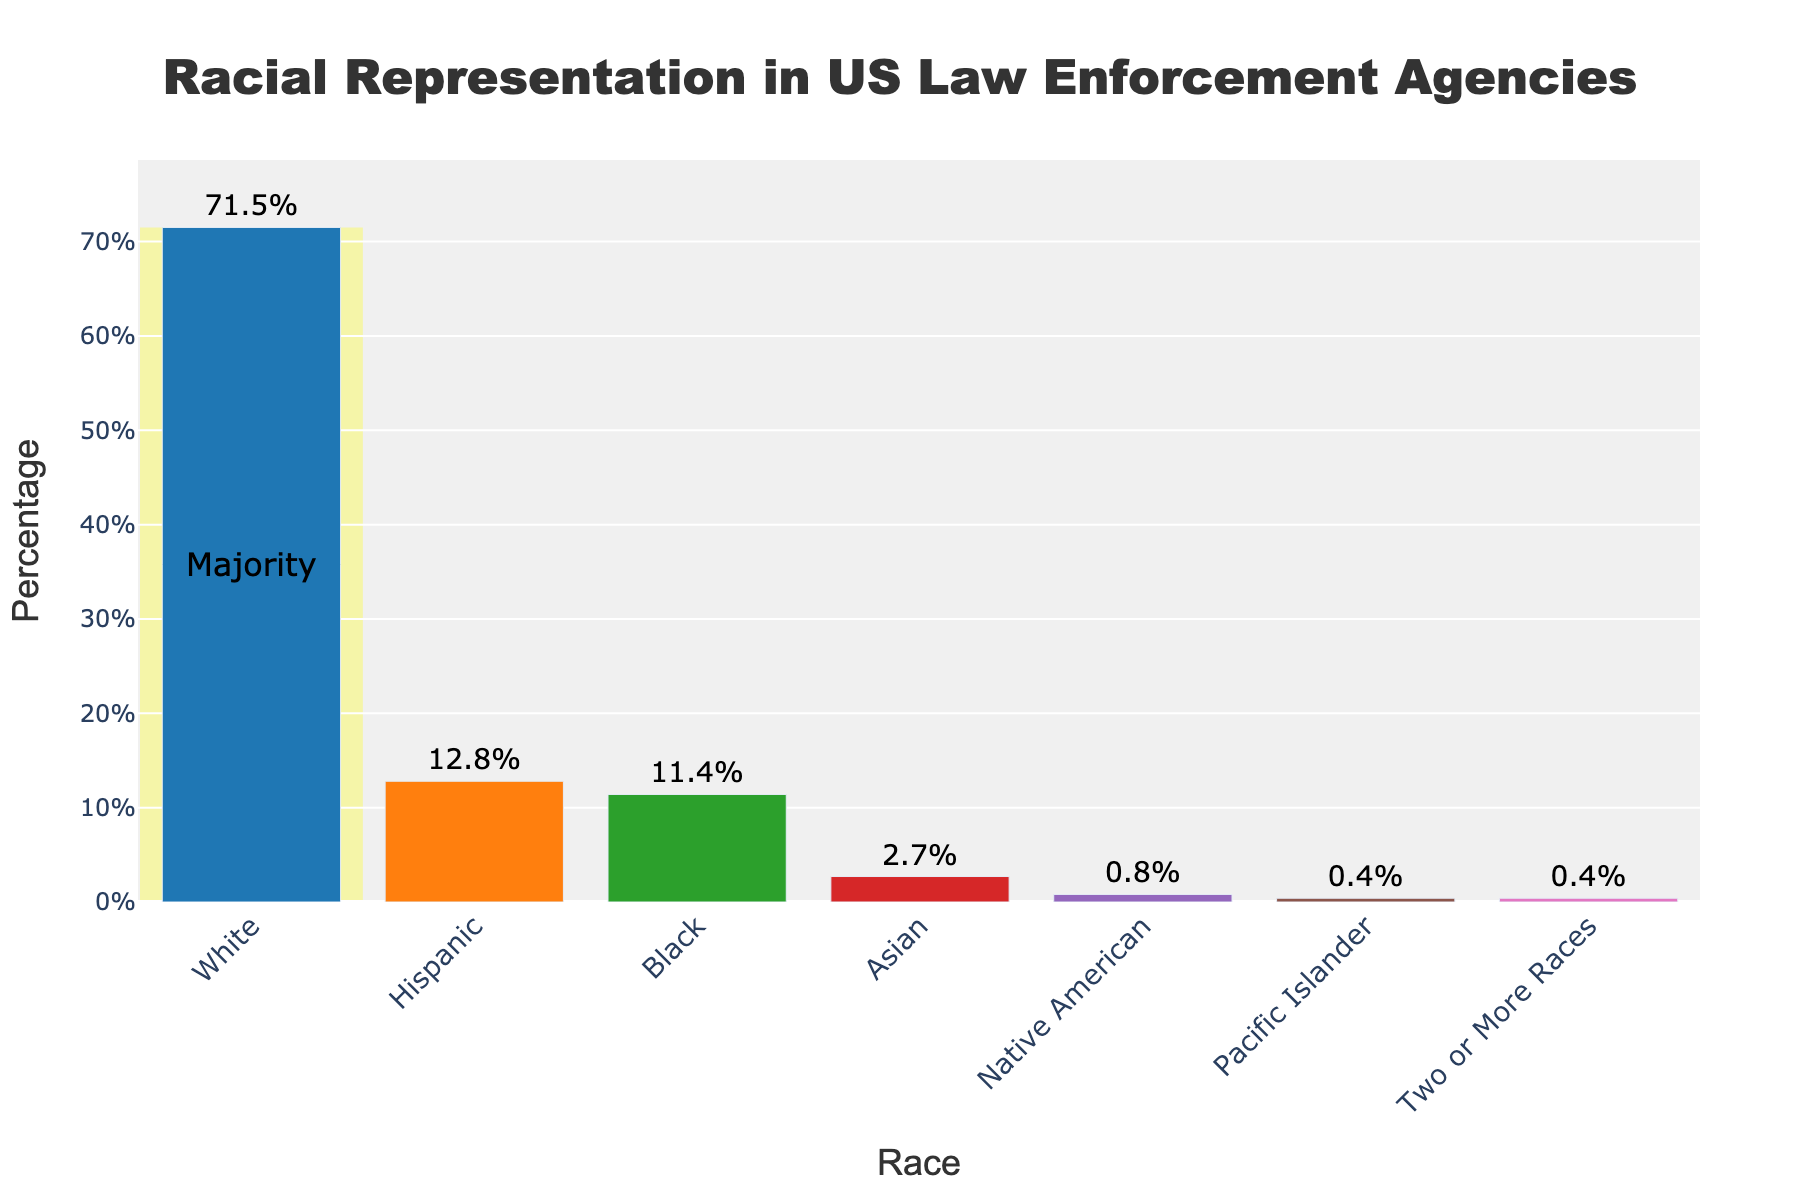What's the racial group with the highest representation in US law enforcement agencies? The figure shows the percentage values for different racial groups. The highest bar represents the White group at 71.5%.
Answer: White Which two racial groups have the closest representation percentages? The figure shows the Black group at 11.4% and the Hispanic group at 12.8%. The difference between them is the smallest among other groups.
Answer: Black and Hispanic What's the total percentage of law enforcement that identify as Pacific Islander, Native American, and Two or More Races together? The Pacific Islander group is 0.4%, the Native American group is 0.8%, and Two or More Races is 0.4%. Summing them up: 0.4 + 0.8 + 0.4 = 1.6%.
Answer: 1.6% Is the percentage of Black representation greater than the Asian representation? The chart indicates that the Black group represents 11.4%, while the Asian group represents 2.7%. 11.4% is greater than 2.7%.
Answer: Yes What is the difference in representation between the Hispanic and Black groups? The figure shows the Hispanic group at 12.8% and the Black group at 11.4%. The difference is 12.8 - 11.4 = 1.4%.
Answer: 1.4% Which racial group has the smallest representation percentage? The shortest bar in the figure, representing the smallest percentage, is for Pacific Islander at 0.4%.
Answer: Pacific Islander How much greater is White representation compared to Asian representation? The White representation is 71.5% and Asian is 2.7%. The difference is 71.5 - 2.7 = 68.8%.
Answer: 68.8% What's the total representation percentage of minority groups (non-White) in US law enforcement agencies? The sum of Hispanic (12.8%), Black (11.4%), Asian (2.7%), Native American (0.8%), Pacific Islander (0.4%), and Two or More Races (0.4%) is: 12.8 + 11.4 + 2.7 + 0.8 + 0.4 + 0.4 = 28.5%.
Answer: 28.5% Which color bar represents the Native American group? Upon observing the figure, the Native American group is represented with a color distinct from others, isolated between Asian (2.7%) and Pacific Islander (0.4%). Look directly at each bar's label and color combination.
Answer: The fifth color bar from the left What's the average percentage representation of Black and Asian groups combined? The Black group's representation is 11.4% and the Asian group's is 2.7%. Their combined average can be calculated as (11.4 + 2.7) / 2 = 7.05%.
Answer: 7.05% 